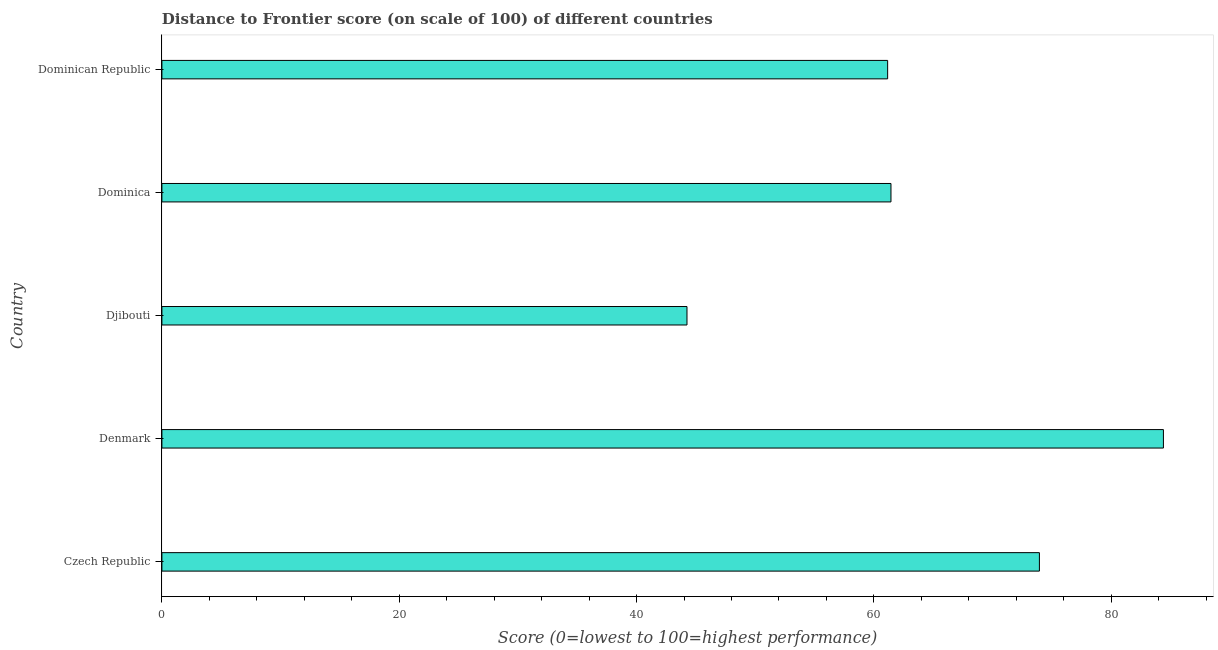Does the graph contain any zero values?
Your answer should be compact. No. What is the title of the graph?
Your response must be concise. Distance to Frontier score (on scale of 100) of different countries. What is the label or title of the X-axis?
Make the answer very short. Score (0=lowest to 100=highest performance). What is the label or title of the Y-axis?
Offer a terse response. Country. What is the distance to frontier score in Denmark?
Provide a succinct answer. 84.4. Across all countries, what is the maximum distance to frontier score?
Keep it short and to the point. 84.4. Across all countries, what is the minimum distance to frontier score?
Your answer should be compact. 44.25. In which country was the distance to frontier score minimum?
Keep it short and to the point. Djibouti. What is the sum of the distance to frontier score?
Offer a terse response. 325.2. What is the difference between the distance to frontier score in Czech Republic and Djibouti?
Offer a terse response. 29.7. What is the average distance to frontier score per country?
Your response must be concise. 65.04. What is the median distance to frontier score?
Ensure brevity in your answer.  61.44. What is the ratio of the distance to frontier score in Czech Republic to that in Dominica?
Provide a succinct answer. 1.2. What is the difference between the highest and the second highest distance to frontier score?
Make the answer very short. 10.45. What is the difference between the highest and the lowest distance to frontier score?
Your answer should be compact. 40.15. In how many countries, is the distance to frontier score greater than the average distance to frontier score taken over all countries?
Your response must be concise. 2. What is the difference between two consecutive major ticks on the X-axis?
Give a very brief answer. 20. What is the Score (0=lowest to 100=highest performance) in Czech Republic?
Make the answer very short. 73.95. What is the Score (0=lowest to 100=highest performance) in Denmark?
Your response must be concise. 84.4. What is the Score (0=lowest to 100=highest performance) in Djibouti?
Your answer should be compact. 44.25. What is the Score (0=lowest to 100=highest performance) in Dominica?
Keep it short and to the point. 61.44. What is the Score (0=lowest to 100=highest performance) of Dominican Republic?
Ensure brevity in your answer.  61.16. What is the difference between the Score (0=lowest to 100=highest performance) in Czech Republic and Denmark?
Make the answer very short. -10.45. What is the difference between the Score (0=lowest to 100=highest performance) in Czech Republic and Djibouti?
Provide a short and direct response. 29.7. What is the difference between the Score (0=lowest to 100=highest performance) in Czech Republic and Dominica?
Provide a succinct answer. 12.51. What is the difference between the Score (0=lowest to 100=highest performance) in Czech Republic and Dominican Republic?
Offer a terse response. 12.79. What is the difference between the Score (0=lowest to 100=highest performance) in Denmark and Djibouti?
Offer a terse response. 40.15. What is the difference between the Score (0=lowest to 100=highest performance) in Denmark and Dominica?
Your answer should be compact. 22.96. What is the difference between the Score (0=lowest to 100=highest performance) in Denmark and Dominican Republic?
Provide a short and direct response. 23.24. What is the difference between the Score (0=lowest to 100=highest performance) in Djibouti and Dominica?
Make the answer very short. -17.19. What is the difference between the Score (0=lowest to 100=highest performance) in Djibouti and Dominican Republic?
Your answer should be very brief. -16.91. What is the difference between the Score (0=lowest to 100=highest performance) in Dominica and Dominican Republic?
Offer a terse response. 0.28. What is the ratio of the Score (0=lowest to 100=highest performance) in Czech Republic to that in Denmark?
Give a very brief answer. 0.88. What is the ratio of the Score (0=lowest to 100=highest performance) in Czech Republic to that in Djibouti?
Make the answer very short. 1.67. What is the ratio of the Score (0=lowest to 100=highest performance) in Czech Republic to that in Dominica?
Provide a succinct answer. 1.2. What is the ratio of the Score (0=lowest to 100=highest performance) in Czech Republic to that in Dominican Republic?
Provide a succinct answer. 1.21. What is the ratio of the Score (0=lowest to 100=highest performance) in Denmark to that in Djibouti?
Make the answer very short. 1.91. What is the ratio of the Score (0=lowest to 100=highest performance) in Denmark to that in Dominica?
Your response must be concise. 1.37. What is the ratio of the Score (0=lowest to 100=highest performance) in Denmark to that in Dominican Republic?
Provide a short and direct response. 1.38. What is the ratio of the Score (0=lowest to 100=highest performance) in Djibouti to that in Dominica?
Make the answer very short. 0.72. What is the ratio of the Score (0=lowest to 100=highest performance) in Djibouti to that in Dominican Republic?
Keep it short and to the point. 0.72. 